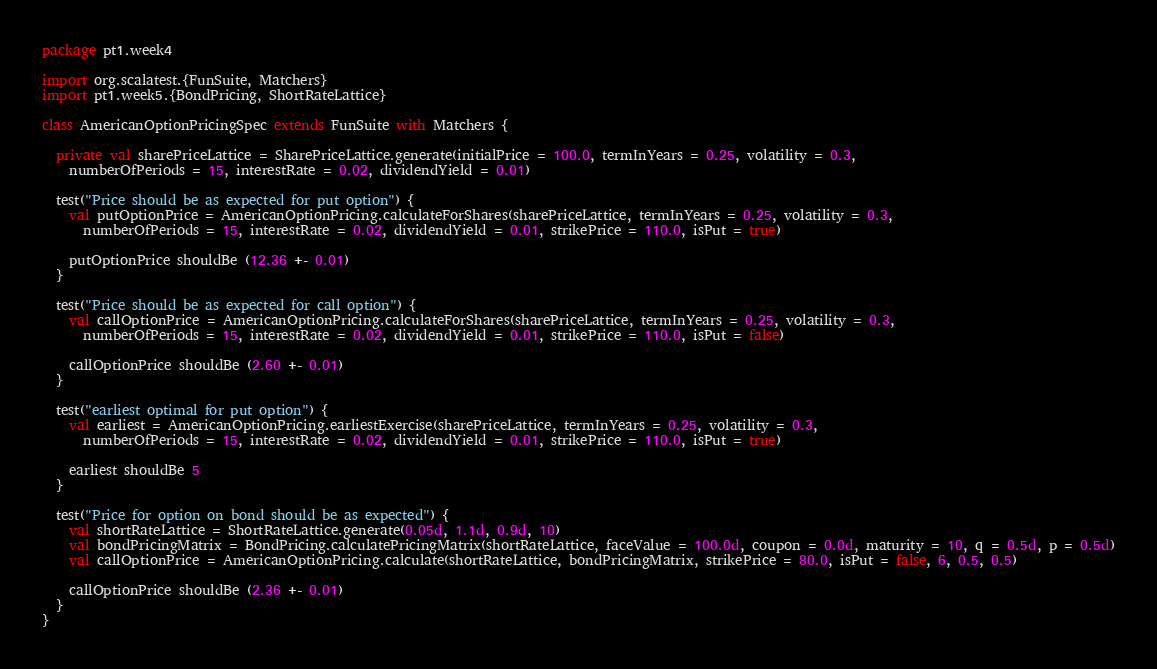Convert code to text. <code><loc_0><loc_0><loc_500><loc_500><_Scala_>package pt1.week4

import org.scalatest.{FunSuite, Matchers}
import pt1.week5.{BondPricing, ShortRateLattice}

class AmericanOptionPricingSpec extends FunSuite with Matchers {

  private val sharePriceLattice = SharePriceLattice.generate(initialPrice = 100.0, termInYears = 0.25, volatility = 0.3,
    numberOfPeriods = 15, interestRate = 0.02, dividendYield = 0.01)

  test("Price should be as expected for put option") {
    val putOptionPrice = AmericanOptionPricing.calculateForShares(sharePriceLattice, termInYears = 0.25, volatility = 0.3,
      numberOfPeriods = 15, interestRate = 0.02, dividendYield = 0.01, strikePrice = 110.0, isPut = true)

    putOptionPrice shouldBe (12.36 +- 0.01)
  }

  test("Price should be as expected for call option") {
    val callOptionPrice = AmericanOptionPricing.calculateForShares(sharePriceLattice, termInYears = 0.25, volatility = 0.3,
      numberOfPeriods = 15, interestRate = 0.02, dividendYield = 0.01, strikePrice = 110.0, isPut = false)

    callOptionPrice shouldBe (2.60 +- 0.01)
  }

  test("earliest optimal for put option") {
    val earliest = AmericanOptionPricing.earliestExercise(sharePriceLattice, termInYears = 0.25, volatility = 0.3,
      numberOfPeriods = 15, interestRate = 0.02, dividendYield = 0.01, strikePrice = 110.0, isPut = true)

    earliest shouldBe 5
  }

  test("Price for option on bond should be as expected") {
    val shortRateLattice = ShortRateLattice.generate(0.05d, 1.1d, 0.9d, 10)
    val bondPricingMatrix = BondPricing.calculatePricingMatrix(shortRateLattice, faceValue = 100.0d, coupon = 0.0d, maturity = 10, q = 0.5d, p = 0.5d)
    val callOptionPrice = AmericanOptionPricing.calculate(shortRateLattice, bondPricingMatrix, strikePrice = 80.0, isPut = false, 6, 0.5, 0.5)

    callOptionPrice shouldBe (2.36 +- 0.01)
  }
}
</code> 